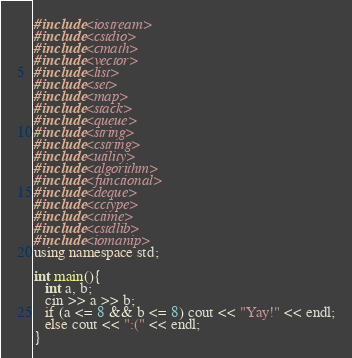<code> <loc_0><loc_0><loc_500><loc_500><_C++_>#include<iostream>
#include<cstdio>
#include<cmath>
#include<vector>
#include<list>
#include<set>
#include<map>
#include<stack>
#include<queue>
#include<string>
#include<cstring>
#include<utility>
#include<algorithm>
#include<functional>
#include<deque>
#include<cctype>
#include<ctime>
#include<cstdlib>
#include<iomanip>
using namespace std;

int main(){
   int a, b;
   cin >> a >> b;
   if (a <= 8 && b <= 8) cout << "Yay!" << endl;
   else cout << ":(" << endl;
}
</code> 